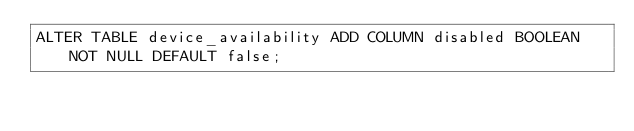<code> <loc_0><loc_0><loc_500><loc_500><_SQL_>ALTER TABLE device_availability ADD COLUMN disabled BOOLEAN NOT NULL DEFAULT false;</code> 